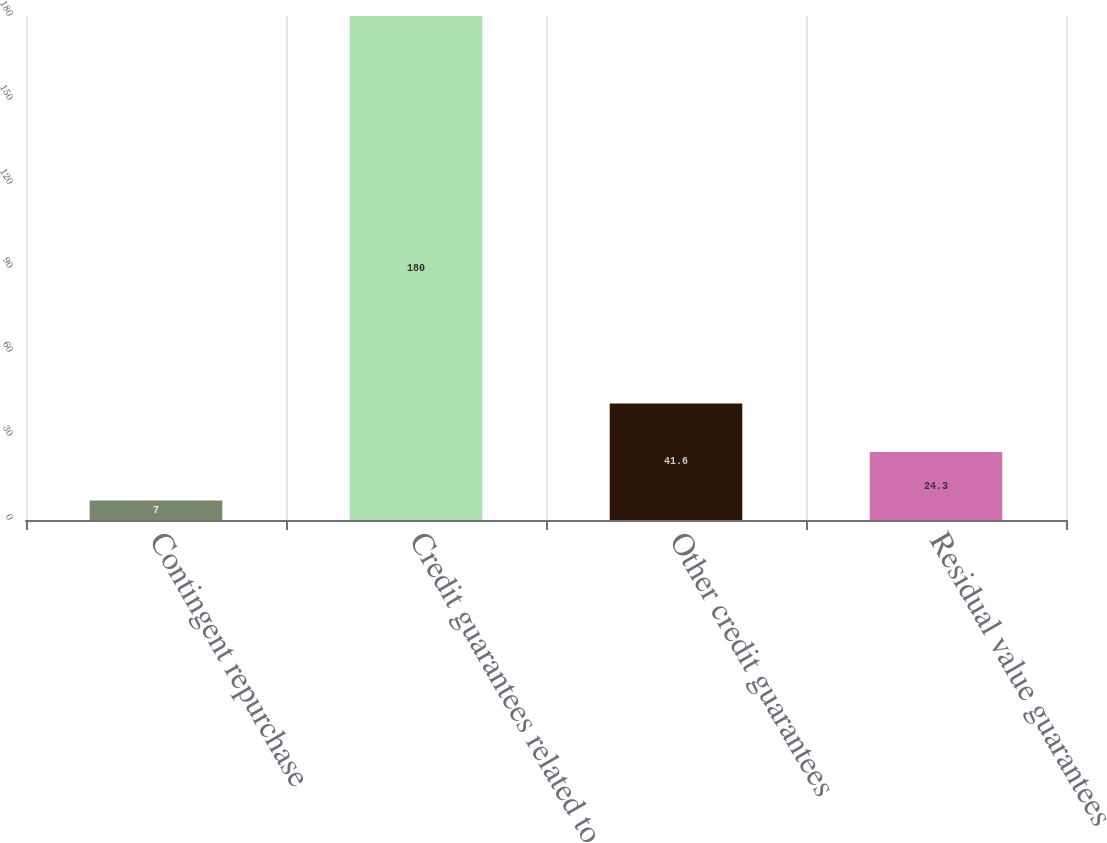Convert chart to OTSL. <chart><loc_0><loc_0><loc_500><loc_500><bar_chart><fcel>Contingent repurchase<fcel>Credit guarantees related to<fcel>Other credit guarantees<fcel>Residual value guarantees<nl><fcel>7<fcel>180<fcel>41.6<fcel>24.3<nl></chart> 